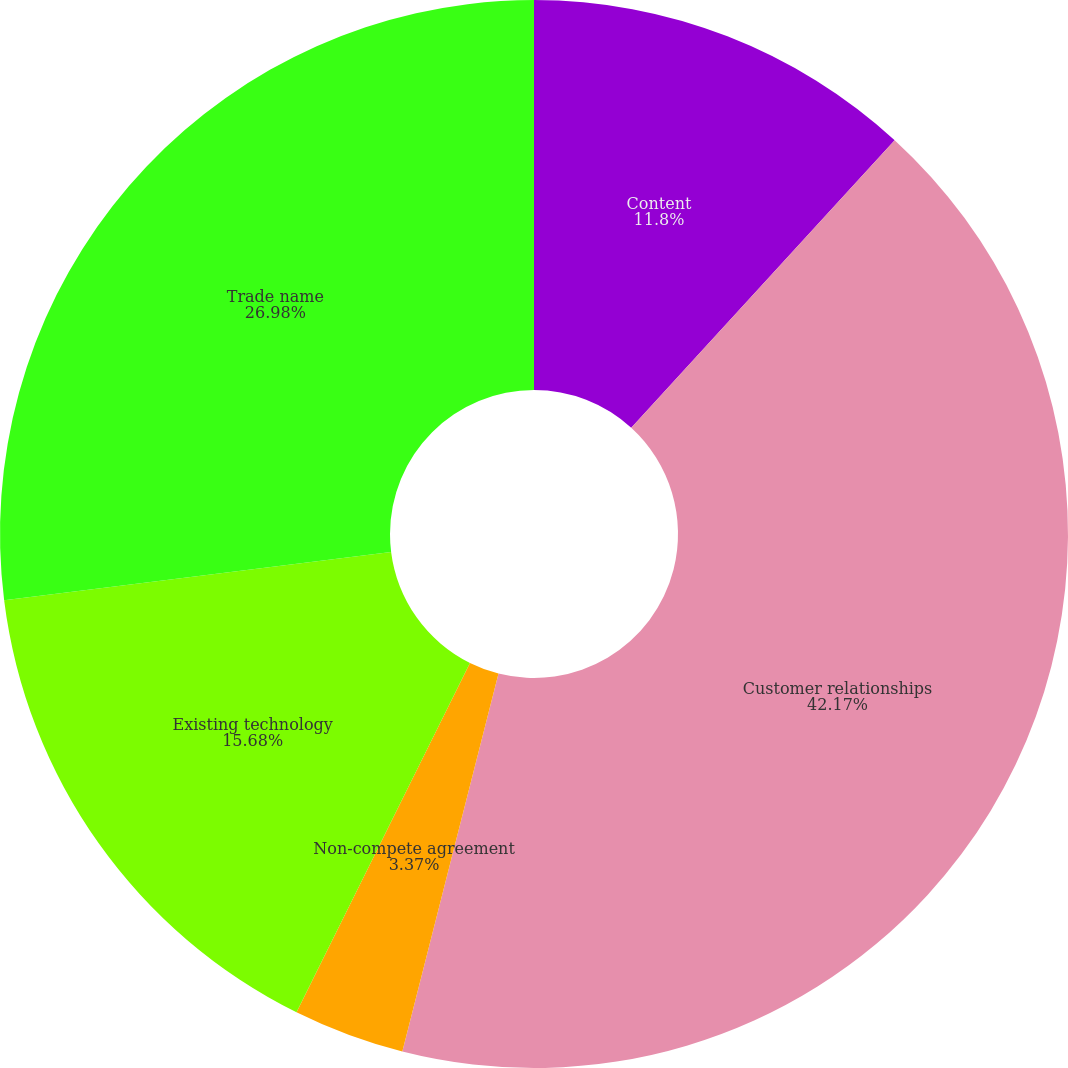Convert chart. <chart><loc_0><loc_0><loc_500><loc_500><pie_chart><fcel>Content<fcel>Customer relationships<fcel>Non-compete agreement<fcel>Existing technology<fcel>Trade name<nl><fcel>11.8%<fcel>42.16%<fcel>3.37%<fcel>15.68%<fcel>26.98%<nl></chart> 